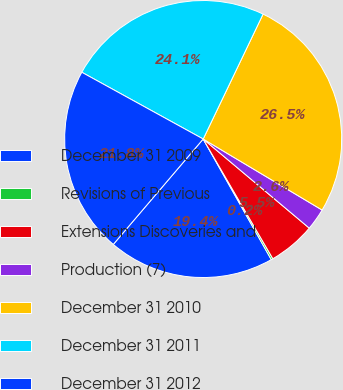Convert chart. <chart><loc_0><loc_0><loc_500><loc_500><pie_chart><fcel>December 31 2009<fcel>Revisions of Previous<fcel>Extensions Discoveries and<fcel>Production (7)<fcel>December 31 2010<fcel>December 31 2011<fcel>December 31 2012<nl><fcel>19.42%<fcel>0.21%<fcel>5.49%<fcel>2.55%<fcel>26.45%<fcel>24.11%<fcel>21.76%<nl></chart> 